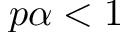<formula> <loc_0><loc_0><loc_500><loc_500>p \alpha < 1</formula> 